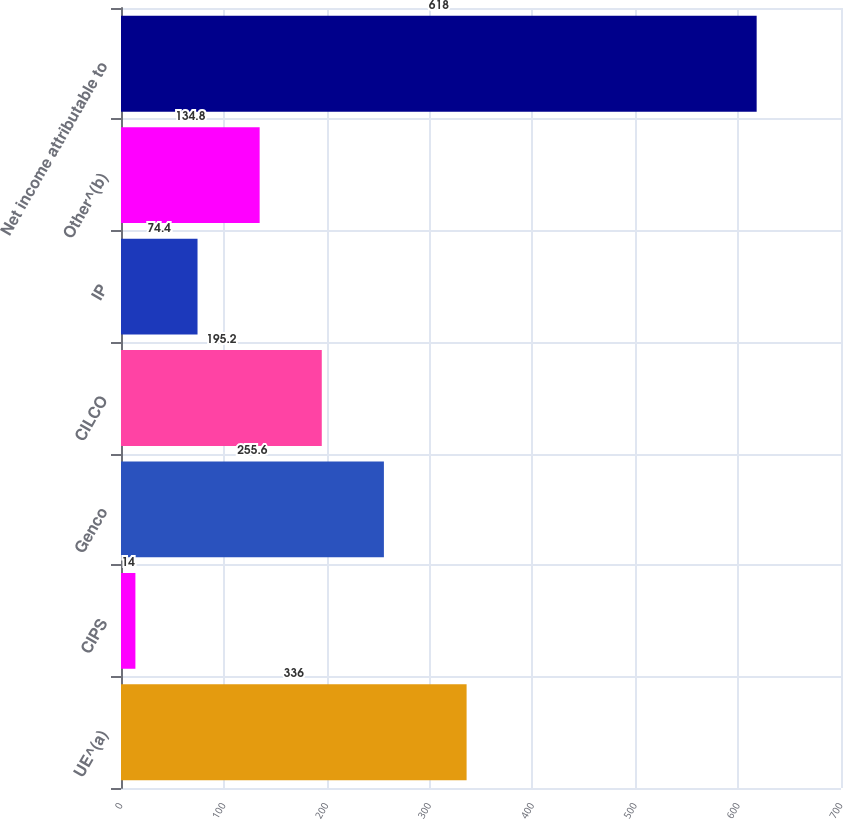Convert chart to OTSL. <chart><loc_0><loc_0><loc_500><loc_500><bar_chart><fcel>UE^(a)<fcel>CIPS<fcel>Genco<fcel>CILCO<fcel>IP<fcel>Other^(b)<fcel>Net income attributable to<nl><fcel>336<fcel>14<fcel>255.6<fcel>195.2<fcel>74.4<fcel>134.8<fcel>618<nl></chart> 